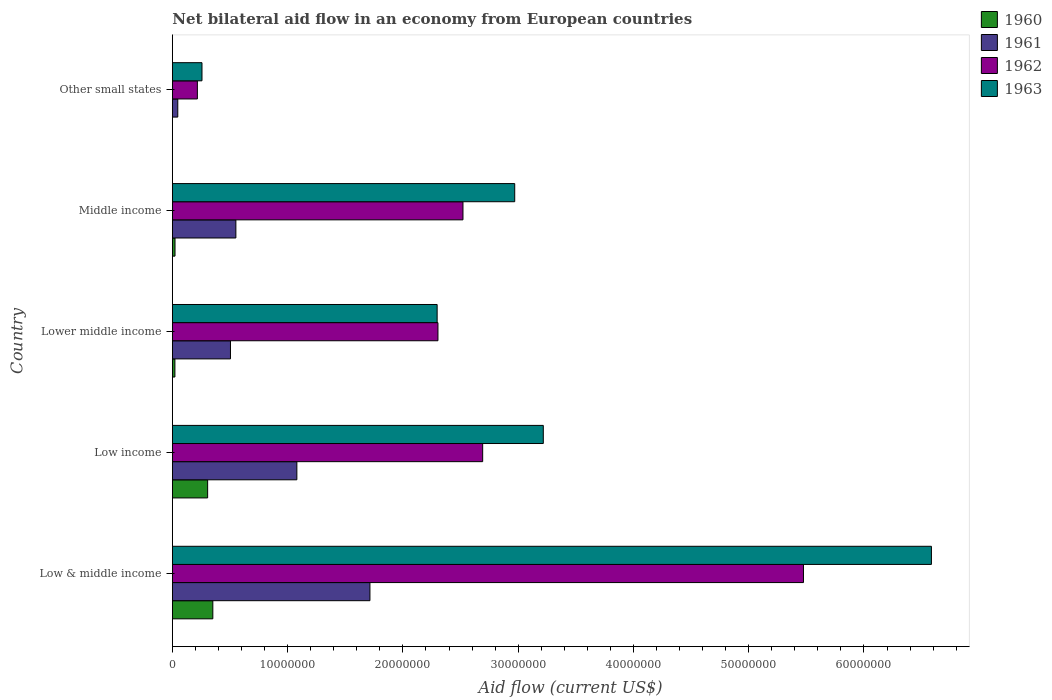How many groups of bars are there?
Ensure brevity in your answer.  5. Are the number of bars per tick equal to the number of legend labels?
Offer a terse response. Yes. Are the number of bars on each tick of the Y-axis equal?
Keep it short and to the point. Yes. How many bars are there on the 1st tick from the top?
Ensure brevity in your answer.  4. What is the net bilateral aid flow in 1963 in Other small states?
Your answer should be very brief. 2.57e+06. Across all countries, what is the maximum net bilateral aid flow in 1960?
Keep it short and to the point. 3.51e+06. Across all countries, what is the minimum net bilateral aid flow in 1960?
Keep it short and to the point. 10000. In which country was the net bilateral aid flow in 1960 maximum?
Your answer should be compact. Low & middle income. In which country was the net bilateral aid flow in 1960 minimum?
Ensure brevity in your answer.  Other small states. What is the total net bilateral aid flow in 1962 in the graph?
Your answer should be compact. 1.32e+08. What is the difference between the net bilateral aid flow in 1961 in Low income and that in Middle income?
Provide a succinct answer. 5.29e+06. What is the difference between the net bilateral aid flow in 1961 in Middle income and the net bilateral aid flow in 1963 in Low & middle income?
Offer a very short reply. -6.03e+07. What is the average net bilateral aid flow in 1963 per country?
Make the answer very short. 3.07e+07. What is the difference between the net bilateral aid flow in 1961 and net bilateral aid flow in 1962 in Lower middle income?
Offer a terse response. -1.80e+07. What is the ratio of the net bilateral aid flow in 1960 in Low & middle income to that in Low income?
Your response must be concise. 1.15. What is the difference between the highest and the second highest net bilateral aid flow in 1961?
Provide a short and direct response. 6.34e+06. What is the difference between the highest and the lowest net bilateral aid flow in 1962?
Provide a short and direct response. 5.26e+07. What does the 2nd bar from the top in Lower middle income represents?
Give a very brief answer. 1962. What does the 2nd bar from the bottom in Low income represents?
Provide a succinct answer. 1961. Are all the bars in the graph horizontal?
Your answer should be compact. Yes. Are the values on the major ticks of X-axis written in scientific E-notation?
Keep it short and to the point. No. Does the graph contain any zero values?
Provide a succinct answer. No. Where does the legend appear in the graph?
Provide a succinct answer. Top right. How many legend labels are there?
Your answer should be compact. 4. What is the title of the graph?
Offer a very short reply. Net bilateral aid flow in an economy from European countries. What is the Aid flow (current US$) in 1960 in Low & middle income?
Offer a terse response. 3.51e+06. What is the Aid flow (current US$) in 1961 in Low & middle income?
Your response must be concise. 1.71e+07. What is the Aid flow (current US$) in 1962 in Low & middle income?
Ensure brevity in your answer.  5.48e+07. What is the Aid flow (current US$) in 1963 in Low & middle income?
Give a very brief answer. 6.58e+07. What is the Aid flow (current US$) of 1960 in Low income?
Offer a very short reply. 3.06e+06. What is the Aid flow (current US$) of 1961 in Low income?
Offer a very short reply. 1.08e+07. What is the Aid flow (current US$) of 1962 in Low income?
Ensure brevity in your answer.  2.69e+07. What is the Aid flow (current US$) of 1963 in Low income?
Ensure brevity in your answer.  3.22e+07. What is the Aid flow (current US$) of 1961 in Lower middle income?
Keep it short and to the point. 5.04e+06. What is the Aid flow (current US$) of 1962 in Lower middle income?
Provide a succinct answer. 2.30e+07. What is the Aid flow (current US$) in 1963 in Lower middle income?
Make the answer very short. 2.30e+07. What is the Aid flow (current US$) of 1961 in Middle income?
Offer a terse response. 5.51e+06. What is the Aid flow (current US$) of 1962 in Middle income?
Make the answer very short. 2.52e+07. What is the Aid flow (current US$) of 1963 in Middle income?
Provide a short and direct response. 2.97e+07. What is the Aid flow (current US$) in 1960 in Other small states?
Provide a short and direct response. 10000. What is the Aid flow (current US$) of 1962 in Other small states?
Offer a very short reply. 2.17e+06. What is the Aid flow (current US$) in 1963 in Other small states?
Make the answer very short. 2.57e+06. Across all countries, what is the maximum Aid flow (current US$) in 1960?
Your response must be concise. 3.51e+06. Across all countries, what is the maximum Aid flow (current US$) in 1961?
Provide a succinct answer. 1.71e+07. Across all countries, what is the maximum Aid flow (current US$) of 1962?
Provide a short and direct response. 5.48e+07. Across all countries, what is the maximum Aid flow (current US$) in 1963?
Give a very brief answer. 6.58e+07. Across all countries, what is the minimum Aid flow (current US$) of 1961?
Make the answer very short. 4.70e+05. Across all countries, what is the minimum Aid flow (current US$) in 1962?
Your answer should be compact. 2.17e+06. Across all countries, what is the minimum Aid flow (current US$) in 1963?
Keep it short and to the point. 2.57e+06. What is the total Aid flow (current US$) of 1960 in the graph?
Offer a terse response. 7.03e+06. What is the total Aid flow (current US$) of 1961 in the graph?
Offer a very short reply. 3.90e+07. What is the total Aid flow (current US$) of 1962 in the graph?
Your answer should be compact. 1.32e+08. What is the total Aid flow (current US$) of 1963 in the graph?
Provide a succinct answer. 1.53e+08. What is the difference between the Aid flow (current US$) of 1961 in Low & middle income and that in Low income?
Make the answer very short. 6.34e+06. What is the difference between the Aid flow (current US$) of 1962 in Low & middle income and that in Low income?
Your answer should be very brief. 2.78e+07. What is the difference between the Aid flow (current US$) of 1963 in Low & middle income and that in Low income?
Provide a short and direct response. 3.37e+07. What is the difference between the Aid flow (current US$) of 1960 in Low & middle income and that in Lower middle income?
Provide a succinct answer. 3.29e+06. What is the difference between the Aid flow (current US$) of 1961 in Low & middle income and that in Lower middle income?
Your answer should be compact. 1.21e+07. What is the difference between the Aid flow (current US$) of 1962 in Low & middle income and that in Lower middle income?
Keep it short and to the point. 3.17e+07. What is the difference between the Aid flow (current US$) in 1963 in Low & middle income and that in Lower middle income?
Provide a short and direct response. 4.29e+07. What is the difference between the Aid flow (current US$) in 1960 in Low & middle income and that in Middle income?
Give a very brief answer. 3.28e+06. What is the difference between the Aid flow (current US$) of 1961 in Low & middle income and that in Middle income?
Offer a very short reply. 1.16e+07. What is the difference between the Aid flow (current US$) of 1962 in Low & middle income and that in Middle income?
Keep it short and to the point. 2.95e+07. What is the difference between the Aid flow (current US$) of 1963 in Low & middle income and that in Middle income?
Make the answer very short. 3.62e+07. What is the difference between the Aid flow (current US$) in 1960 in Low & middle income and that in Other small states?
Your answer should be compact. 3.50e+06. What is the difference between the Aid flow (current US$) in 1961 in Low & middle income and that in Other small states?
Offer a terse response. 1.67e+07. What is the difference between the Aid flow (current US$) in 1962 in Low & middle income and that in Other small states?
Your answer should be very brief. 5.26e+07. What is the difference between the Aid flow (current US$) in 1963 in Low & middle income and that in Other small states?
Your response must be concise. 6.33e+07. What is the difference between the Aid flow (current US$) in 1960 in Low income and that in Lower middle income?
Give a very brief answer. 2.84e+06. What is the difference between the Aid flow (current US$) of 1961 in Low income and that in Lower middle income?
Your answer should be very brief. 5.76e+06. What is the difference between the Aid flow (current US$) of 1962 in Low income and that in Lower middle income?
Your response must be concise. 3.88e+06. What is the difference between the Aid flow (current US$) of 1963 in Low income and that in Lower middle income?
Make the answer very short. 9.21e+06. What is the difference between the Aid flow (current US$) of 1960 in Low income and that in Middle income?
Your answer should be very brief. 2.83e+06. What is the difference between the Aid flow (current US$) in 1961 in Low income and that in Middle income?
Give a very brief answer. 5.29e+06. What is the difference between the Aid flow (current US$) of 1962 in Low income and that in Middle income?
Your answer should be compact. 1.71e+06. What is the difference between the Aid flow (current US$) of 1963 in Low income and that in Middle income?
Your answer should be very brief. 2.48e+06. What is the difference between the Aid flow (current US$) in 1960 in Low income and that in Other small states?
Give a very brief answer. 3.05e+06. What is the difference between the Aid flow (current US$) in 1961 in Low income and that in Other small states?
Your answer should be very brief. 1.03e+07. What is the difference between the Aid flow (current US$) in 1962 in Low income and that in Other small states?
Offer a very short reply. 2.48e+07. What is the difference between the Aid flow (current US$) of 1963 in Low income and that in Other small states?
Your answer should be very brief. 2.96e+07. What is the difference between the Aid flow (current US$) of 1960 in Lower middle income and that in Middle income?
Provide a succinct answer. -10000. What is the difference between the Aid flow (current US$) in 1961 in Lower middle income and that in Middle income?
Your answer should be compact. -4.70e+05. What is the difference between the Aid flow (current US$) of 1962 in Lower middle income and that in Middle income?
Your answer should be compact. -2.17e+06. What is the difference between the Aid flow (current US$) of 1963 in Lower middle income and that in Middle income?
Keep it short and to the point. -6.73e+06. What is the difference between the Aid flow (current US$) in 1961 in Lower middle income and that in Other small states?
Your answer should be compact. 4.57e+06. What is the difference between the Aid flow (current US$) in 1962 in Lower middle income and that in Other small states?
Offer a terse response. 2.09e+07. What is the difference between the Aid flow (current US$) in 1963 in Lower middle income and that in Other small states?
Give a very brief answer. 2.04e+07. What is the difference between the Aid flow (current US$) in 1960 in Middle income and that in Other small states?
Provide a succinct answer. 2.20e+05. What is the difference between the Aid flow (current US$) in 1961 in Middle income and that in Other small states?
Your answer should be compact. 5.04e+06. What is the difference between the Aid flow (current US$) in 1962 in Middle income and that in Other small states?
Offer a terse response. 2.30e+07. What is the difference between the Aid flow (current US$) in 1963 in Middle income and that in Other small states?
Keep it short and to the point. 2.71e+07. What is the difference between the Aid flow (current US$) of 1960 in Low & middle income and the Aid flow (current US$) of 1961 in Low income?
Make the answer very short. -7.29e+06. What is the difference between the Aid flow (current US$) in 1960 in Low & middle income and the Aid flow (current US$) in 1962 in Low income?
Offer a very short reply. -2.34e+07. What is the difference between the Aid flow (current US$) of 1960 in Low & middle income and the Aid flow (current US$) of 1963 in Low income?
Ensure brevity in your answer.  -2.87e+07. What is the difference between the Aid flow (current US$) of 1961 in Low & middle income and the Aid flow (current US$) of 1962 in Low income?
Keep it short and to the point. -9.78e+06. What is the difference between the Aid flow (current US$) of 1961 in Low & middle income and the Aid flow (current US$) of 1963 in Low income?
Provide a short and direct response. -1.50e+07. What is the difference between the Aid flow (current US$) in 1962 in Low & middle income and the Aid flow (current US$) in 1963 in Low income?
Ensure brevity in your answer.  2.26e+07. What is the difference between the Aid flow (current US$) of 1960 in Low & middle income and the Aid flow (current US$) of 1961 in Lower middle income?
Offer a very short reply. -1.53e+06. What is the difference between the Aid flow (current US$) of 1960 in Low & middle income and the Aid flow (current US$) of 1962 in Lower middle income?
Your answer should be compact. -1.95e+07. What is the difference between the Aid flow (current US$) in 1960 in Low & middle income and the Aid flow (current US$) in 1963 in Lower middle income?
Offer a very short reply. -1.95e+07. What is the difference between the Aid flow (current US$) of 1961 in Low & middle income and the Aid flow (current US$) of 1962 in Lower middle income?
Keep it short and to the point. -5.90e+06. What is the difference between the Aid flow (current US$) in 1961 in Low & middle income and the Aid flow (current US$) in 1963 in Lower middle income?
Provide a succinct answer. -5.83e+06. What is the difference between the Aid flow (current US$) of 1962 in Low & middle income and the Aid flow (current US$) of 1963 in Lower middle income?
Make the answer very short. 3.18e+07. What is the difference between the Aid flow (current US$) in 1960 in Low & middle income and the Aid flow (current US$) in 1962 in Middle income?
Your response must be concise. -2.17e+07. What is the difference between the Aid flow (current US$) of 1960 in Low & middle income and the Aid flow (current US$) of 1963 in Middle income?
Offer a very short reply. -2.62e+07. What is the difference between the Aid flow (current US$) of 1961 in Low & middle income and the Aid flow (current US$) of 1962 in Middle income?
Make the answer very short. -8.07e+06. What is the difference between the Aid flow (current US$) of 1961 in Low & middle income and the Aid flow (current US$) of 1963 in Middle income?
Make the answer very short. -1.26e+07. What is the difference between the Aid flow (current US$) in 1962 in Low & middle income and the Aid flow (current US$) in 1963 in Middle income?
Give a very brief answer. 2.50e+07. What is the difference between the Aid flow (current US$) in 1960 in Low & middle income and the Aid flow (current US$) in 1961 in Other small states?
Your response must be concise. 3.04e+06. What is the difference between the Aid flow (current US$) of 1960 in Low & middle income and the Aid flow (current US$) of 1962 in Other small states?
Keep it short and to the point. 1.34e+06. What is the difference between the Aid flow (current US$) in 1960 in Low & middle income and the Aid flow (current US$) in 1963 in Other small states?
Keep it short and to the point. 9.40e+05. What is the difference between the Aid flow (current US$) in 1961 in Low & middle income and the Aid flow (current US$) in 1962 in Other small states?
Your answer should be compact. 1.50e+07. What is the difference between the Aid flow (current US$) of 1961 in Low & middle income and the Aid flow (current US$) of 1963 in Other small states?
Give a very brief answer. 1.46e+07. What is the difference between the Aid flow (current US$) of 1962 in Low & middle income and the Aid flow (current US$) of 1963 in Other small states?
Ensure brevity in your answer.  5.22e+07. What is the difference between the Aid flow (current US$) in 1960 in Low income and the Aid flow (current US$) in 1961 in Lower middle income?
Offer a very short reply. -1.98e+06. What is the difference between the Aid flow (current US$) of 1960 in Low income and the Aid flow (current US$) of 1962 in Lower middle income?
Your response must be concise. -2.00e+07. What is the difference between the Aid flow (current US$) of 1960 in Low income and the Aid flow (current US$) of 1963 in Lower middle income?
Give a very brief answer. -1.99e+07. What is the difference between the Aid flow (current US$) of 1961 in Low income and the Aid flow (current US$) of 1962 in Lower middle income?
Provide a succinct answer. -1.22e+07. What is the difference between the Aid flow (current US$) in 1961 in Low income and the Aid flow (current US$) in 1963 in Lower middle income?
Your answer should be compact. -1.22e+07. What is the difference between the Aid flow (current US$) of 1962 in Low income and the Aid flow (current US$) of 1963 in Lower middle income?
Give a very brief answer. 3.95e+06. What is the difference between the Aid flow (current US$) in 1960 in Low income and the Aid flow (current US$) in 1961 in Middle income?
Your answer should be very brief. -2.45e+06. What is the difference between the Aid flow (current US$) of 1960 in Low income and the Aid flow (current US$) of 1962 in Middle income?
Ensure brevity in your answer.  -2.22e+07. What is the difference between the Aid flow (current US$) of 1960 in Low income and the Aid flow (current US$) of 1963 in Middle income?
Provide a succinct answer. -2.66e+07. What is the difference between the Aid flow (current US$) of 1961 in Low income and the Aid flow (current US$) of 1962 in Middle income?
Make the answer very short. -1.44e+07. What is the difference between the Aid flow (current US$) of 1961 in Low income and the Aid flow (current US$) of 1963 in Middle income?
Make the answer very short. -1.89e+07. What is the difference between the Aid flow (current US$) of 1962 in Low income and the Aid flow (current US$) of 1963 in Middle income?
Make the answer very short. -2.78e+06. What is the difference between the Aid flow (current US$) in 1960 in Low income and the Aid flow (current US$) in 1961 in Other small states?
Offer a very short reply. 2.59e+06. What is the difference between the Aid flow (current US$) in 1960 in Low income and the Aid flow (current US$) in 1962 in Other small states?
Make the answer very short. 8.90e+05. What is the difference between the Aid flow (current US$) in 1960 in Low income and the Aid flow (current US$) in 1963 in Other small states?
Offer a very short reply. 4.90e+05. What is the difference between the Aid flow (current US$) of 1961 in Low income and the Aid flow (current US$) of 1962 in Other small states?
Keep it short and to the point. 8.63e+06. What is the difference between the Aid flow (current US$) of 1961 in Low income and the Aid flow (current US$) of 1963 in Other small states?
Provide a succinct answer. 8.23e+06. What is the difference between the Aid flow (current US$) in 1962 in Low income and the Aid flow (current US$) in 1963 in Other small states?
Keep it short and to the point. 2.44e+07. What is the difference between the Aid flow (current US$) in 1960 in Lower middle income and the Aid flow (current US$) in 1961 in Middle income?
Your answer should be compact. -5.29e+06. What is the difference between the Aid flow (current US$) in 1960 in Lower middle income and the Aid flow (current US$) in 1962 in Middle income?
Provide a succinct answer. -2.50e+07. What is the difference between the Aid flow (current US$) in 1960 in Lower middle income and the Aid flow (current US$) in 1963 in Middle income?
Keep it short and to the point. -2.95e+07. What is the difference between the Aid flow (current US$) of 1961 in Lower middle income and the Aid flow (current US$) of 1962 in Middle income?
Provide a short and direct response. -2.02e+07. What is the difference between the Aid flow (current US$) in 1961 in Lower middle income and the Aid flow (current US$) in 1963 in Middle income?
Offer a terse response. -2.47e+07. What is the difference between the Aid flow (current US$) of 1962 in Lower middle income and the Aid flow (current US$) of 1963 in Middle income?
Give a very brief answer. -6.66e+06. What is the difference between the Aid flow (current US$) in 1960 in Lower middle income and the Aid flow (current US$) in 1962 in Other small states?
Give a very brief answer. -1.95e+06. What is the difference between the Aid flow (current US$) in 1960 in Lower middle income and the Aid flow (current US$) in 1963 in Other small states?
Offer a very short reply. -2.35e+06. What is the difference between the Aid flow (current US$) in 1961 in Lower middle income and the Aid flow (current US$) in 1962 in Other small states?
Ensure brevity in your answer.  2.87e+06. What is the difference between the Aid flow (current US$) in 1961 in Lower middle income and the Aid flow (current US$) in 1963 in Other small states?
Ensure brevity in your answer.  2.47e+06. What is the difference between the Aid flow (current US$) in 1962 in Lower middle income and the Aid flow (current US$) in 1963 in Other small states?
Your response must be concise. 2.05e+07. What is the difference between the Aid flow (current US$) of 1960 in Middle income and the Aid flow (current US$) of 1961 in Other small states?
Your response must be concise. -2.40e+05. What is the difference between the Aid flow (current US$) in 1960 in Middle income and the Aid flow (current US$) in 1962 in Other small states?
Ensure brevity in your answer.  -1.94e+06. What is the difference between the Aid flow (current US$) of 1960 in Middle income and the Aid flow (current US$) of 1963 in Other small states?
Offer a terse response. -2.34e+06. What is the difference between the Aid flow (current US$) in 1961 in Middle income and the Aid flow (current US$) in 1962 in Other small states?
Offer a very short reply. 3.34e+06. What is the difference between the Aid flow (current US$) in 1961 in Middle income and the Aid flow (current US$) in 1963 in Other small states?
Your response must be concise. 2.94e+06. What is the difference between the Aid flow (current US$) of 1962 in Middle income and the Aid flow (current US$) of 1963 in Other small states?
Make the answer very short. 2.26e+07. What is the average Aid flow (current US$) in 1960 per country?
Your answer should be very brief. 1.41e+06. What is the average Aid flow (current US$) of 1961 per country?
Give a very brief answer. 7.79e+06. What is the average Aid flow (current US$) of 1962 per country?
Offer a terse response. 2.64e+07. What is the average Aid flow (current US$) in 1963 per country?
Make the answer very short. 3.07e+07. What is the difference between the Aid flow (current US$) of 1960 and Aid flow (current US$) of 1961 in Low & middle income?
Your answer should be very brief. -1.36e+07. What is the difference between the Aid flow (current US$) of 1960 and Aid flow (current US$) of 1962 in Low & middle income?
Offer a very short reply. -5.12e+07. What is the difference between the Aid flow (current US$) in 1960 and Aid flow (current US$) in 1963 in Low & middle income?
Your answer should be very brief. -6.23e+07. What is the difference between the Aid flow (current US$) of 1961 and Aid flow (current US$) of 1962 in Low & middle income?
Ensure brevity in your answer.  -3.76e+07. What is the difference between the Aid flow (current US$) of 1961 and Aid flow (current US$) of 1963 in Low & middle income?
Your response must be concise. -4.87e+07. What is the difference between the Aid flow (current US$) of 1962 and Aid flow (current US$) of 1963 in Low & middle income?
Your response must be concise. -1.11e+07. What is the difference between the Aid flow (current US$) in 1960 and Aid flow (current US$) in 1961 in Low income?
Your answer should be very brief. -7.74e+06. What is the difference between the Aid flow (current US$) of 1960 and Aid flow (current US$) of 1962 in Low income?
Give a very brief answer. -2.39e+07. What is the difference between the Aid flow (current US$) in 1960 and Aid flow (current US$) in 1963 in Low income?
Provide a short and direct response. -2.91e+07. What is the difference between the Aid flow (current US$) of 1961 and Aid flow (current US$) of 1962 in Low income?
Keep it short and to the point. -1.61e+07. What is the difference between the Aid flow (current US$) in 1961 and Aid flow (current US$) in 1963 in Low income?
Provide a succinct answer. -2.14e+07. What is the difference between the Aid flow (current US$) in 1962 and Aid flow (current US$) in 1963 in Low income?
Offer a terse response. -5.26e+06. What is the difference between the Aid flow (current US$) of 1960 and Aid flow (current US$) of 1961 in Lower middle income?
Provide a short and direct response. -4.82e+06. What is the difference between the Aid flow (current US$) in 1960 and Aid flow (current US$) in 1962 in Lower middle income?
Offer a terse response. -2.28e+07. What is the difference between the Aid flow (current US$) in 1960 and Aid flow (current US$) in 1963 in Lower middle income?
Your answer should be very brief. -2.28e+07. What is the difference between the Aid flow (current US$) in 1961 and Aid flow (current US$) in 1962 in Lower middle income?
Provide a succinct answer. -1.80e+07. What is the difference between the Aid flow (current US$) in 1961 and Aid flow (current US$) in 1963 in Lower middle income?
Your response must be concise. -1.79e+07. What is the difference between the Aid flow (current US$) of 1960 and Aid flow (current US$) of 1961 in Middle income?
Offer a terse response. -5.28e+06. What is the difference between the Aid flow (current US$) in 1960 and Aid flow (current US$) in 1962 in Middle income?
Ensure brevity in your answer.  -2.50e+07. What is the difference between the Aid flow (current US$) of 1960 and Aid flow (current US$) of 1963 in Middle income?
Keep it short and to the point. -2.95e+07. What is the difference between the Aid flow (current US$) of 1961 and Aid flow (current US$) of 1962 in Middle income?
Keep it short and to the point. -1.97e+07. What is the difference between the Aid flow (current US$) of 1961 and Aid flow (current US$) of 1963 in Middle income?
Offer a very short reply. -2.42e+07. What is the difference between the Aid flow (current US$) in 1962 and Aid flow (current US$) in 1963 in Middle income?
Your answer should be very brief. -4.49e+06. What is the difference between the Aid flow (current US$) in 1960 and Aid flow (current US$) in 1961 in Other small states?
Offer a terse response. -4.60e+05. What is the difference between the Aid flow (current US$) of 1960 and Aid flow (current US$) of 1962 in Other small states?
Offer a terse response. -2.16e+06. What is the difference between the Aid flow (current US$) of 1960 and Aid flow (current US$) of 1963 in Other small states?
Provide a succinct answer. -2.56e+06. What is the difference between the Aid flow (current US$) in 1961 and Aid flow (current US$) in 1962 in Other small states?
Offer a terse response. -1.70e+06. What is the difference between the Aid flow (current US$) in 1961 and Aid flow (current US$) in 1963 in Other small states?
Your response must be concise. -2.10e+06. What is the difference between the Aid flow (current US$) in 1962 and Aid flow (current US$) in 1963 in Other small states?
Your answer should be very brief. -4.00e+05. What is the ratio of the Aid flow (current US$) in 1960 in Low & middle income to that in Low income?
Provide a short and direct response. 1.15. What is the ratio of the Aid flow (current US$) of 1961 in Low & middle income to that in Low income?
Your response must be concise. 1.59. What is the ratio of the Aid flow (current US$) in 1962 in Low & middle income to that in Low income?
Keep it short and to the point. 2.03. What is the ratio of the Aid flow (current US$) in 1963 in Low & middle income to that in Low income?
Ensure brevity in your answer.  2.05. What is the ratio of the Aid flow (current US$) in 1960 in Low & middle income to that in Lower middle income?
Make the answer very short. 15.95. What is the ratio of the Aid flow (current US$) of 1961 in Low & middle income to that in Lower middle income?
Offer a very short reply. 3.4. What is the ratio of the Aid flow (current US$) in 1962 in Low & middle income to that in Lower middle income?
Your answer should be compact. 2.38. What is the ratio of the Aid flow (current US$) of 1963 in Low & middle income to that in Lower middle income?
Provide a short and direct response. 2.87. What is the ratio of the Aid flow (current US$) in 1960 in Low & middle income to that in Middle income?
Your answer should be compact. 15.26. What is the ratio of the Aid flow (current US$) in 1961 in Low & middle income to that in Middle income?
Keep it short and to the point. 3.11. What is the ratio of the Aid flow (current US$) in 1962 in Low & middle income to that in Middle income?
Provide a succinct answer. 2.17. What is the ratio of the Aid flow (current US$) in 1963 in Low & middle income to that in Middle income?
Provide a short and direct response. 2.22. What is the ratio of the Aid flow (current US$) of 1960 in Low & middle income to that in Other small states?
Provide a short and direct response. 351. What is the ratio of the Aid flow (current US$) of 1961 in Low & middle income to that in Other small states?
Ensure brevity in your answer.  36.47. What is the ratio of the Aid flow (current US$) in 1962 in Low & middle income to that in Other small states?
Your response must be concise. 25.23. What is the ratio of the Aid flow (current US$) in 1963 in Low & middle income to that in Other small states?
Your answer should be compact. 25.62. What is the ratio of the Aid flow (current US$) of 1960 in Low income to that in Lower middle income?
Your answer should be compact. 13.91. What is the ratio of the Aid flow (current US$) in 1961 in Low income to that in Lower middle income?
Offer a very short reply. 2.14. What is the ratio of the Aid flow (current US$) of 1962 in Low income to that in Lower middle income?
Give a very brief answer. 1.17. What is the ratio of the Aid flow (current US$) in 1963 in Low income to that in Lower middle income?
Keep it short and to the point. 1.4. What is the ratio of the Aid flow (current US$) of 1960 in Low income to that in Middle income?
Provide a short and direct response. 13.3. What is the ratio of the Aid flow (current US$) of 1961 in Low income to that in Middle income?
Your answer should be compact. 1.96. What is the ratio of the Aid flow (current US$) in 1962 in Low income to that in Middle income?
Offer a terse response. 1.07. What is the ratio of the Aid flow (current US$) of 1963 in Low income to that in Middle income?
Your answer should be very brief. 1.08. What is the ratio of the Aid flow (current US$) in 1960 in Low income to that in Other small states?
Your answer should be very brief. 306. What is the ratio of the Aid flow (current US$) in 1961 in Low income to that in Other small states?
Provide a short and direct response. 22.98. What is the ratio of the Aid flow (current US$) in 1962 in Low income to that in Other small states?
Make the answer very short. 12.41. What is the ratio of the Aid flow (current US$) in 1963 in Low income to that in Other small states?
Provide a succinct answer. 12.52. What is the ratio of the Aid flow (current US$) in 1960 in Lower middle income to that in Middle income?
Make the answer very short. 0.96. What is the ratio of the Aid flow (current US$) in 1961 in Lower middle income to that in Middle income?
Ensure brevity in your answer.  0.91. What is the ratio of the Aid flow (current US$) of 1962 in Lower middle income to that in Middle income?
Provide a succinct answer. 0.91. What is the ratio of the Aid flow (current US$) of 1963 in Lower middle income to that in Middle income?
Provide a succinct answer. 0.77. What is the ratio of the Aid flow (current US$) in 1960 in Lower middle income to that in Other small states?
Your response must be concise. 22. What is the ratio of the Aid flow (current US$) of 1961 in Lower middle income to that in Other small states?
Ensure brevity in your answer.  10.72. What is the ratio of the Aid flow (current US$) of 1962 in Lower middle income to that in Other small states?
Ensure brevity in your answer.  10.62. What is the ratio of the Aid flow (current US$) of 1963 in Lower middle income to that in Other small states?
Your answer should be very brief. 8.94. What is the ratio of the Aid flow (current US$) of 1961 in Middle income to that in Other small states?
Ensure brevity in your answer.  11.72. What is the ratio of the Aid flow (current US$) in 1962 in Middle income to that in Other small states?
Offer a terse response. 11.62. What is the ratio of the Aid flow (current US$) in 1963 in Middle income to that in Other small states?
Ensure brevity in your answer.  11.56. What is the difference between the highest and the second highest Aid flow (current US$) in 1961?
Offer a terse response. 6.34e+06. What is the difference between the highest and the second highest Aid flow (current US$) of 1962?
Your answer should be very brief. 2.78e+07. What is the difference between the highest and the second highest Aid flow (current US$) of 1963?
Provide a short and direct response. 3.37e+07. What is the difference between the highest and the lowest Aid flow (current US$) of 1960?
Keep it short and to the point. 3.50e+06. What is the difference between the highest and the lowest Aid flow (current US$) of 1961?
Provide a succinct answer. 1.67e+07. What is the difference between the highest and the lowest Aid flow (current US$) in 1962?
Keep it short and to the point. 5.26e+07. What is the difference between the highest and the lowest Aid flow (current US$) of 1963?
Provide a short and direct response. 6.33e+07. 